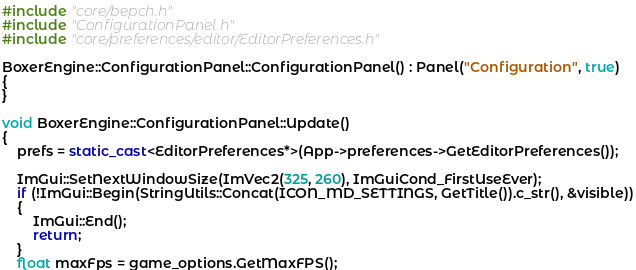<code> <loc_0><loc_0><loc_500><loc_500><_C++_>#include "core/bepch.h"
#include "ConfigurationPanel.h"
#include "core/preferences/editor/EditorPreferences.h"

BoxerEngine::ConfigurationPanel::ConfigurationPanel() : Panel("Configuration", true)
{
}

void BoxerEngine::ConfigurationPanel::Update()
{
    prefs = static_cast<EditorPreferences*>(App->preferences->GetEditorPreferences());

    ImGui::SetNextWindowSize(ImVec2(325, 260), ImGuiCond_FirstUseEver);
    if (!ImGui::Begin(StringUtils::Concat(ICON_MD_SETTINGS, GetTitle()).c_str(), &visible))
    {
        ImGui::End();
        return;
    }
    float maxFps = game_options.GetMaxFPS();</code> 